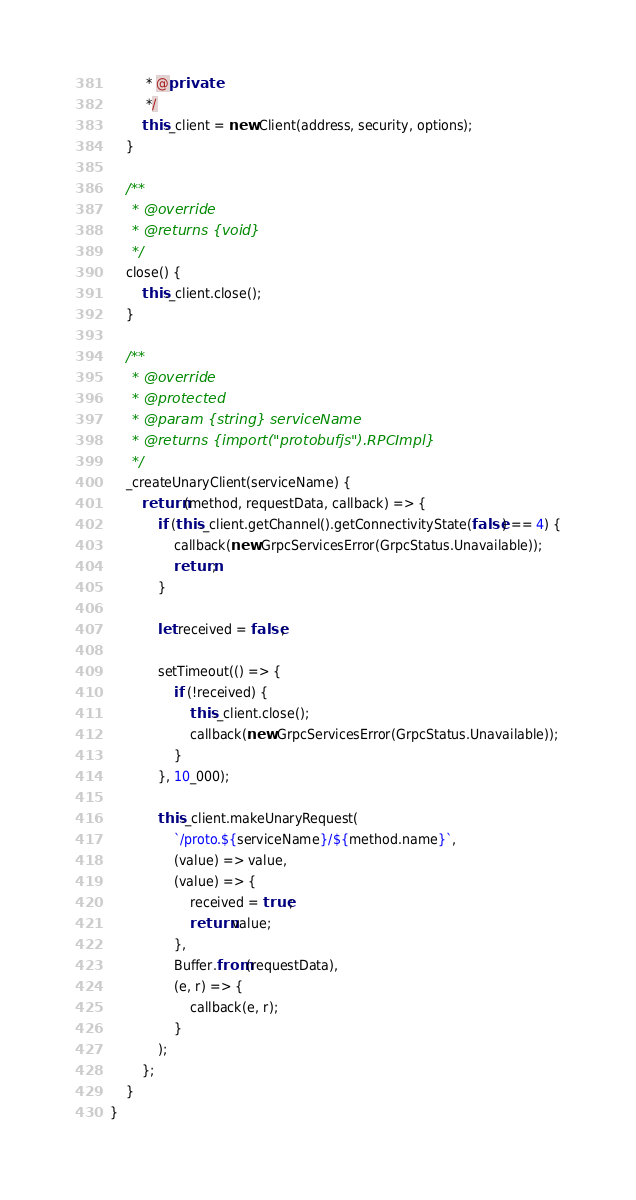Convert code to text. <code><loc_0><loc_0><loc_500><loc_500><_JavaScript_>         * @private
         */
        this._client = new Client(address, security, options);
    }

    /**
     * @override
     * @returns {void}
     */
    close() {
        this._client.close();
    }

    /**
     * @override
     * @protected
     * @param {string} serviceName
     * @returns {import("protobufjs").RPCImpl}
     */
    _createUnaryClient(serviceName) {
        return (method, requestData, callback) => {
            if (this._client.getChannel().getConnectivityState(false) == 4) {
                callback(new GrpcServicesError(GrpcStatus.Unavailable));
                return;
            }

            let received = false;

            setTimeout(() => {
                if (!received) {
                    this._client.close();
                    callback(new GrpcServicesError(GrpcStatus.Unavailable));
                }
            }, 10_000);

            this._client.makeUnaryRequest(
                `/proto.${serviceName}/${method.name}`,
                (value) => value,
                (value) => {
                    received = true;
                    return value;
                },
                Buffer.from(requestData),
                (e, r) => {
                    callback(e, r);
                }
            );
        };
    }
}
</code> 